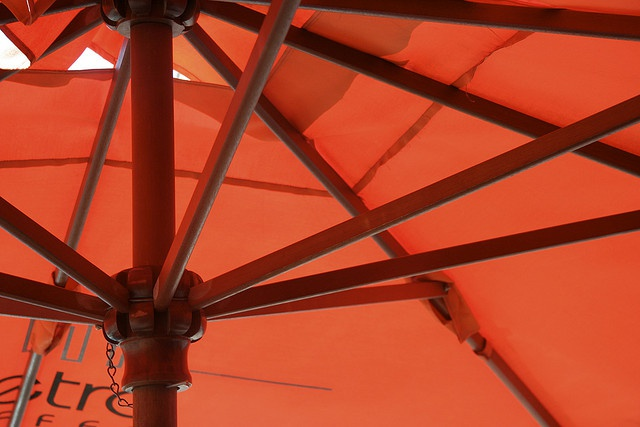Describe the objects in this image and their specific colors. I can see a umbrella in red, maroon, brown, and black tones in this image. 